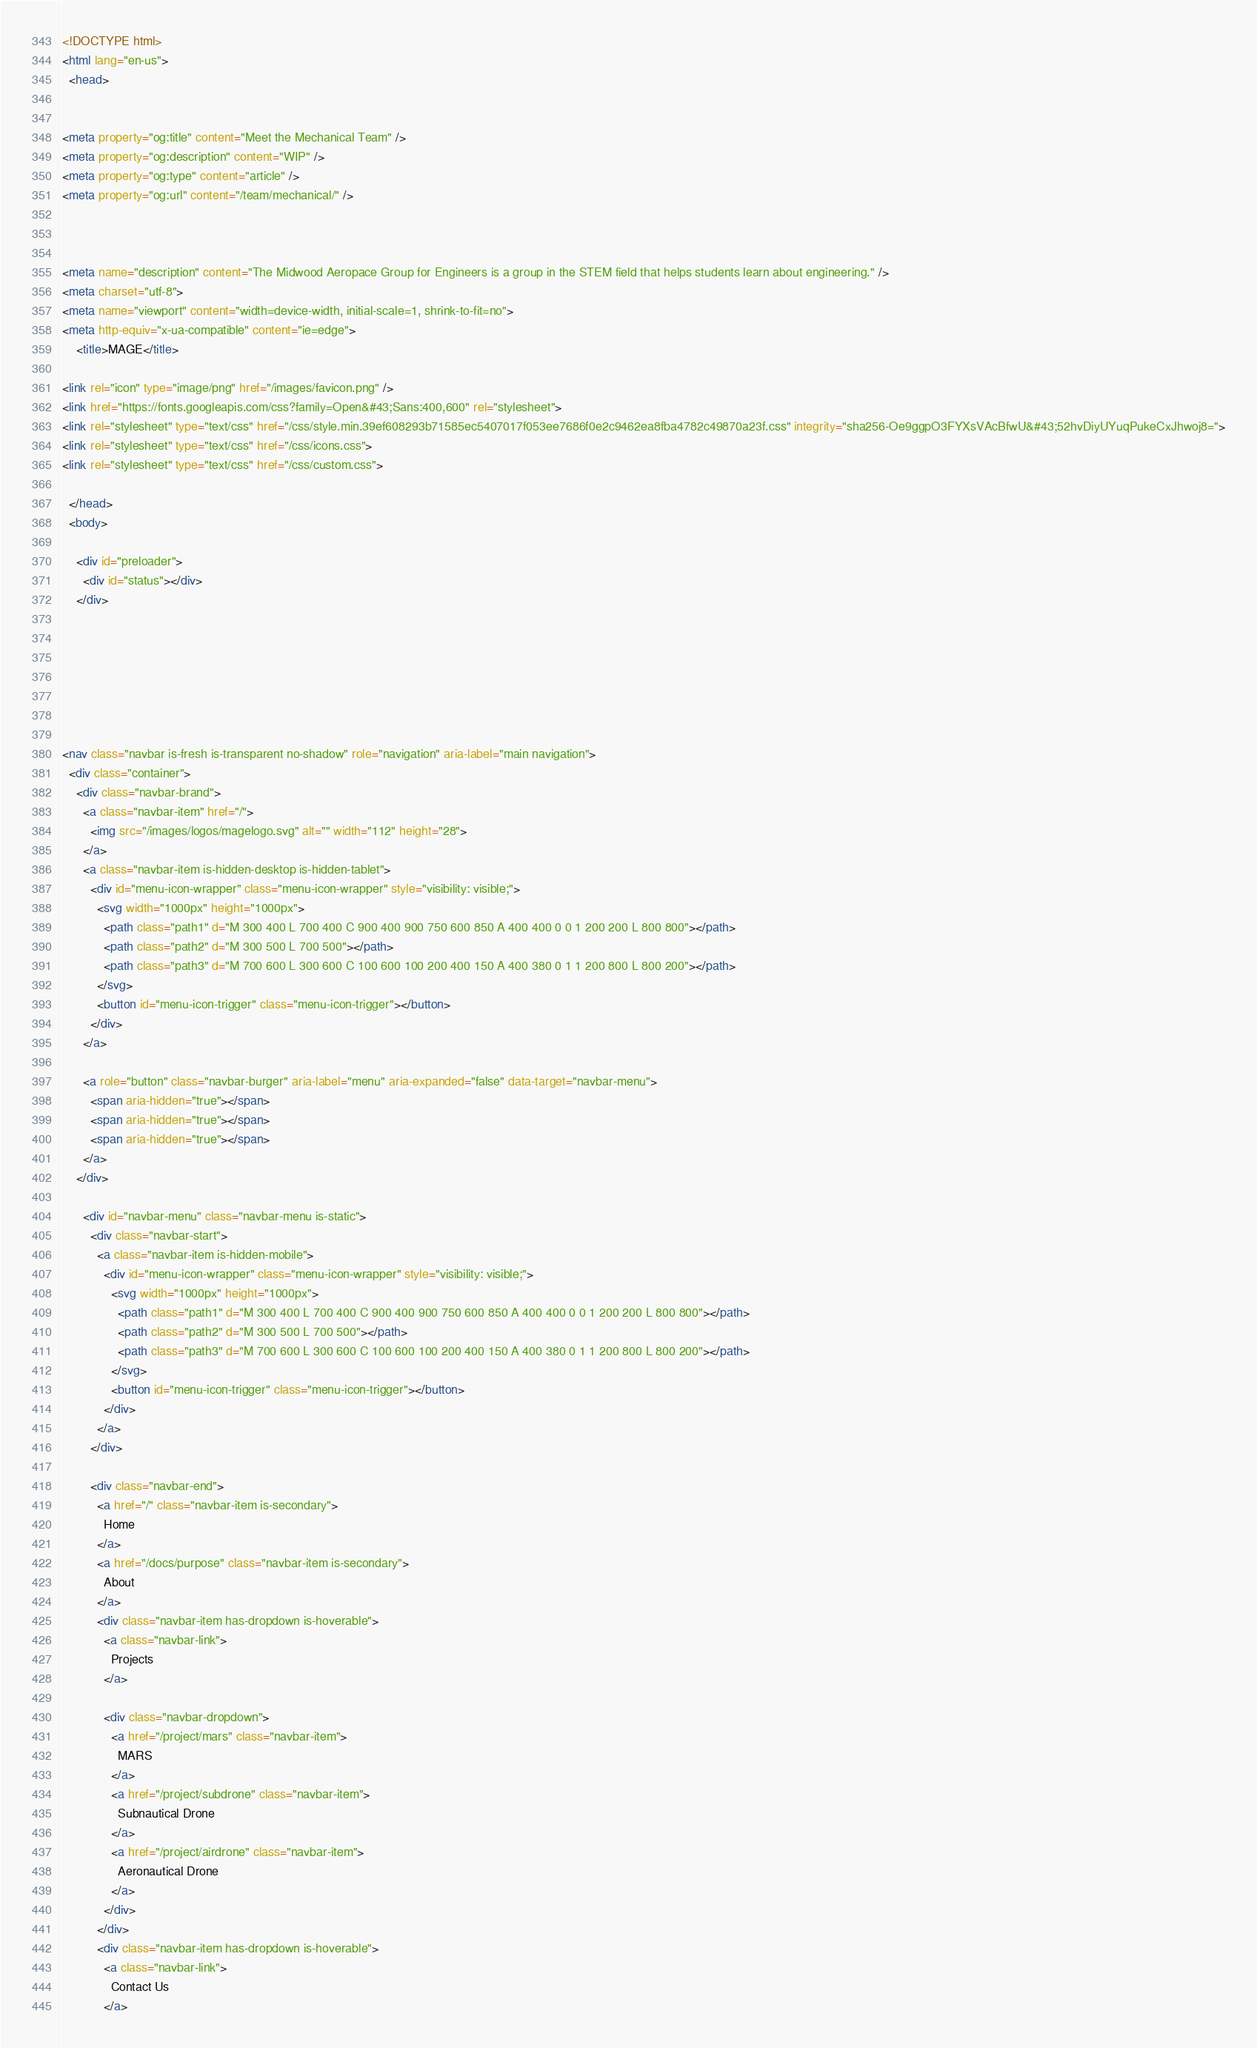<code> <loc_0><loc_0><loc_500><loc_500><_HTML_><!DOCTYPE html>
<html lang="en-us">
  <head>
    

<meta property="og:title" content="Meet the Mechanical Team" />
<meta property="og:description" content="WIP" />
<meta property="og:type" content="article" />
<meta property="og:url" content="/team/mechanical/" />



<meta name="description" content="The Midwood Aeropace Group for Engineers is a group in the STEM field that helps students learn about engineering." />
<meta charset="utf-8">
<meta name="viewport" content="width=device-width, initial-scale=1, shrink-to-fit=no">
<meta http-equiv="x-ua-compatible" content="ie=edge">
    <title>MAGE</title>
    
<link rel="icon" type="image/png" href="/images/favicon.png" />
<link href="https://fonts.googleapis.com/css?family=Open&#43;Sans:400,600" rel="stylesheet">
<link rel="stylesheet" type="text/css" href="/css/style.min.39ef608293b71585ec5407017f053ee7686f0e2c9462ea8fba4782c49870a23f.css" integrity="sha256-Oe9ggpO3FYXsVAcBfwU&#43;52hvDiyUYuqPukeCxJhwoj8=">
<link rel="stylesheet" type="text/css" href="/css/icons.css">
<link rel="stylesheet" type="text/css" href="/css/custom.css">

  </head>
  <body>
    
    <div id="preloader">
      <div id="status"></div>
    </div>

    

    



<nav class="navbar is-fresh is-transparent no-shadow" role="navigation" aria-label="main navigation">
  <div class="container">
    <div class="navbar-brand">
      <a class="navbar-item" href="/">
        <img src="/images/logos/magelogo.svg" alt="" width="112" height="28">
      </a>
      <a class="navbar-item is-hidden-desktop is-hidden-tablet">
        <div id="menu-icon-wrapper" class="menu-icon-wrapper" style="visibility: visible;">
          <svg width="1000px" height="1000px">
            <path class="path1" d="M 300 400 L 700 400 C 900 400 900 750 600 850 A 400 400 0 0 1 200 200 L 800 800"></path>
            <path class="path2" d="M 300 500 L 700 500"></path>
            <path class="path3" d="M 700 600 L 300 600 C 100 600 100 200 400 150 A 400 380 0 1 1 200 800 L 800 200"></path>
          </svg>
          <button id="menu-icon-trigger" class="menu-icon-trigger"></button>
        </div>
      </a>

      <a role="button" class="navbar-burger" aria-label="menu" aria-expanded="false" data-target="navbar-menu">
        <span aria-hidden="true"></span>
        <span aria-hidden="true"></span>
        <span aria-hidden="true"></span>
      </a>
    </div>

      <div id="navbar-menu" class="navbar-menu is-static">
        <div class="navbar-start">
          <a class="navbar-item is-hidden-mobile">
            <div id="menu-icon-wrapper" class="menu-icon-wrapper" style="visibility: visible;">
              <svg width="1000px" height="1000px">
                <path class="path1" d="M 300 400 L 700 400 C 900 400 900 750 600 850 A 400 400 0 0 1 200 200 L 800 800"></path>
                <path class="path2" d="M 300 500 L 700 500"></path>
                <path class="path3" d="M 700 600 L 300 600 C 100 600 100 200 400 150 A 400 380 0 1 1 200 800 L 800 200"></path>
              </svg>
              <button id="menu-icon-trigger" class="menu-icon-trigger"></button>
            </div>
          </a>
        </div>

        <div class="navbar-end">
          <a href="/" class="navbar-item is-secondary">
            Home
          </a>
          <a href="/docs/purpose" class="navbar-item is-secondary">
            About
          </a>
          <div class="navbar-item has-dropdown is-hoverable">
            <a class="navbar-link">
              Projects
            </a>

            <div class="navbar-dropdown">
              <a href="/project/mars" class="navbar-item">
                MARS
              </a>
              <a href="/project/subdrone" class="navbar-item">
                Subnautical Drone
              </a>
              <a href="/project/airdrone" class="navbar-item">
                Aeronautical Drone
              </a>
            </div>
          </div>
          <div class="navbar-item has-dropdown is-hoverable">
            <a class="navbar-link">
              Contact Us
            </a>
</code> 